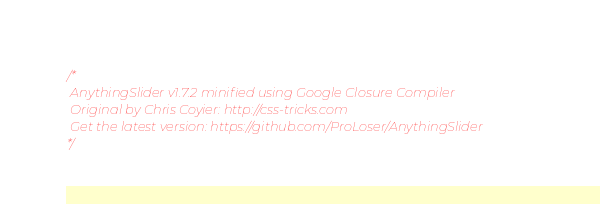Convert code to text. <code><loc_0><loc_0><loc_500><loc_500><_JavaScript_>/*
 AnythingSlider v1.7.2 minified using Google Closure Compiler
 Original by Chris Coyier: http://css-tricks.com
 Get the latest version: https://github.com/ProLoser/AnythingSlider
*/
</code> 